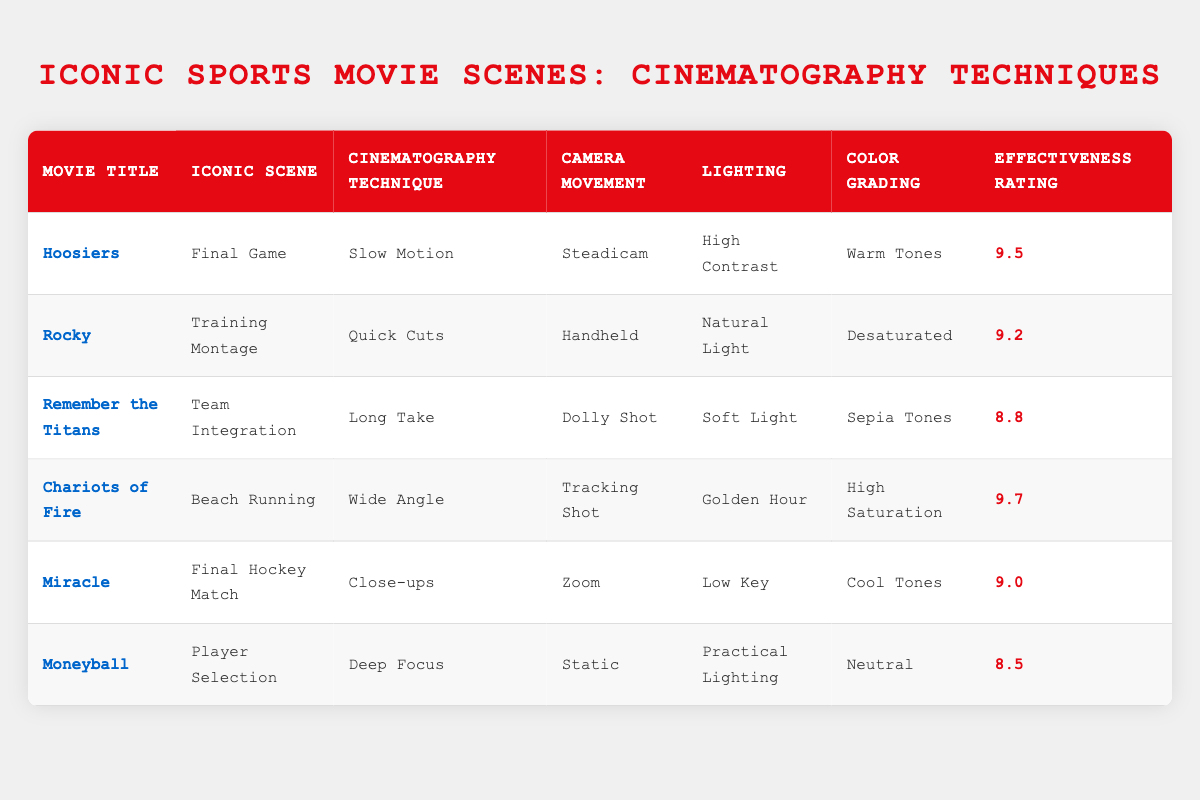What is the effectiveness rating of the movie "Hoosiers"? The table shows that the effectiveness rating for "Hoosiers" is listed under the "Effectiveness Rating" column, which indicates a score of 9.5.
Answer: 9.5 Which iconic scene in "Rocky" uses the cinematography technique of Quick Cuts? According to the table, "Rocky" features the iconic scene "Training Montage" which employs the technique of Quick Cuts.
Answer: Training Montage Is the color grading for "Chariots of Fire" described as warm tones? In the table, the color grading listed for "Chariots of Fire" is "High Saturation", not warm tones. Thus, the statement is false.
Answer: No Which movie has the highest effectiveness rating and what is that rating? By reviewing the effect ratings column, "Chariots of Fire" has the highest rating of 9.7, making it the top-rated movie for cinematography effectiveness.
Answer: Chariots of Fire, 9.7 What is the difference in effectiveness ratings between "Miracle" and "Moneyball"? The effectiveness rating for "Miracle" is 9.0 and for "Moneyball," it's 8.5. To find the difference: 9.0 - 8.5 equals 0.5.
Answer: 0.5 Does "Remember the Titans" utilize a Dolly Shot for camera movement? The table confirms that for "Remember the Titans," the camera movement specified is indeed a Dolly Shot. Therefore, the answer is yes.
Answer: Yes What is the average effectiveness rating of all listed films? To find the average, sum the effectiveness ratings (9.5 + 9.2 + 8.8 + 9.7 + 9.0 + 8.5 = 54.7) and divide by the number of films (6). Thus, 54.7/6 equals approximately 9.12.
Answer: 9.12 Which movie features a long take as a cinematography technique and how effective was it rated? The table indicates that "Remember the Titans" uses a Long Take as its cinematography technique, with an effectiveness rating of 8.8.
Answer: Remember the Titans, 8.8 How many films utilize natural lighting in their iconic scenes? By examining the lighting column for the table, only "Rocky" is noted to use Natural Light. Therefore, there is a total of one film that utilizes this lighting technique.
Answer: 1 